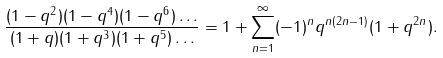Convert formula to latex. <formula><loc_0><loc_0><loc_500><loc_500>\frac { ( 1 - q ^ { 2 } ) ( 1 - q ^ { 4 } ) ( 1 - q ^ { 6 } ) \dots } { ( 1 + q ) ( 1 + q ^ { 3 } ) ( 1 + q ^ { 5 } ) \dots } = 1 + \sum _ { n = 1 } ^ { \infty } ( - 1 ) ^ { n } q ^ { n ( 2 n - 1 ) } ( 1 + q ^ { 2 n } ) .</formula> 